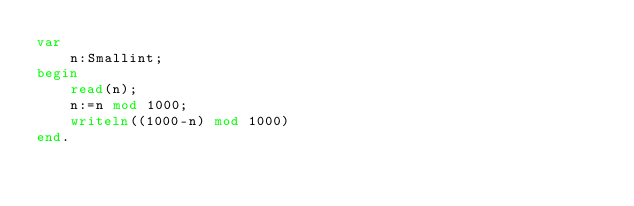<code> <loc_0><loc_0><loc_500><loc_500><_Pascal_>var
	n:Smallint;
begin
    read(n);
    n:=n mod 1000;
    writeln((1000-n) mod 1000)
end.</code> 